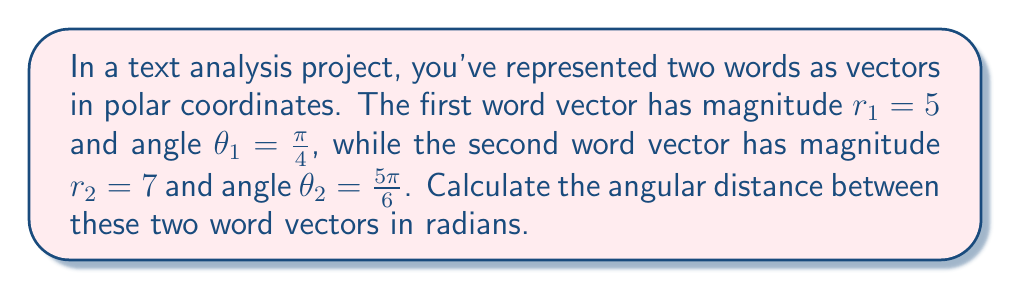Can you solve this math problem? To calculate the angular distance between two vectors in polar coordinates, we need to follow these steps:

1. Identify the angles of both vectors:
   $\theta_1 = \frac{\pi}{4}$
   $\theta_2 = \frac{5\pi}{6}$

2. Calculate the absolute difference between the angles:
   $|\theta_2 - \theta_1| = |\frac{5\pi}{6} - \frac{\pi}{4}|$

3. Simplify the expression:
   $|\frac{5\pi}{6} - \frac{\pi}{4}| = |\frac{10\pi}{12} - \frac{3\pi}{12}| = |\frac{7\pi}{12}|$

4. The angular distance is the smaller of this difference and $2\pi$ minus this difference:
   $\text{Angular Distance} = \min(|\theta_2 - \theta_1|, 2\pi - |\theta_2 - \theta_1|)$

5. Calculate $2\pi - |\theta_2 - \theta_1|$:
   $2\pi - \frac{7\pi}{12} = \frac{24\pi}{12} - \frac{7\pi}{12} = \frac{17\pi}{12}$

6. Compare the two values:
   $\frac{7\pi}{12} < \frac{17\pi}{12}$

Therefore, the angular distance is $\frac{7\pi}{12}$ radians.
Answer: $\frac{7\pi}{12}$ radians 